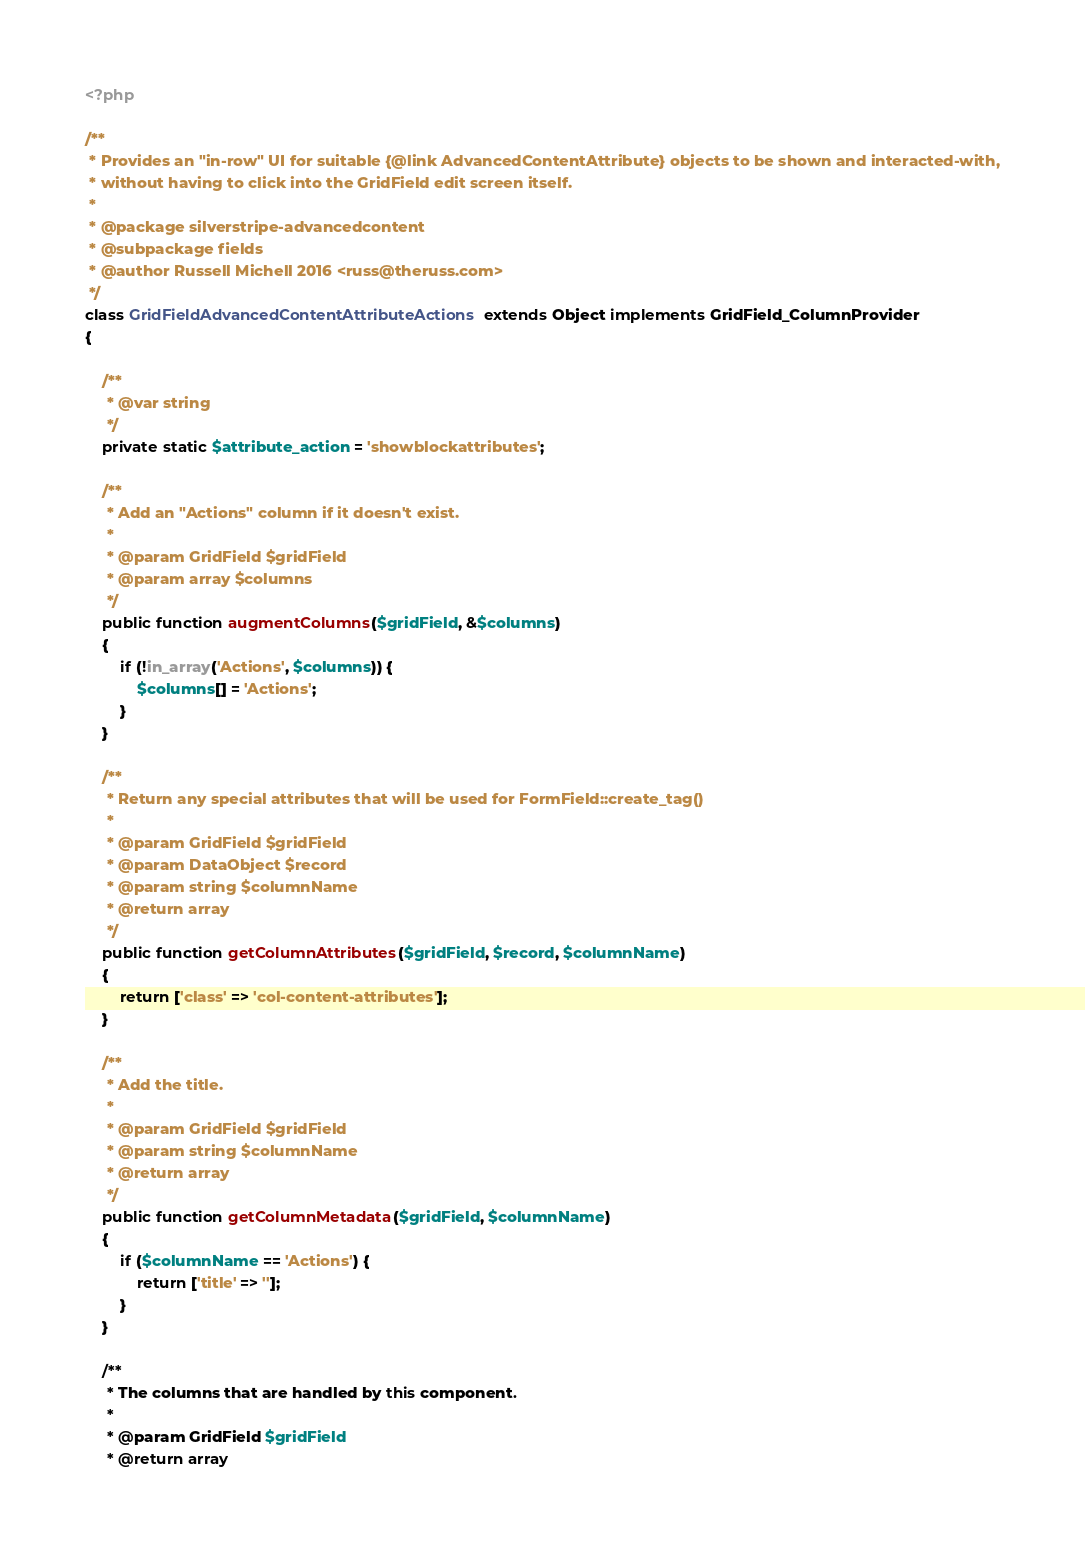<code> <loc_0><loc_0><loc_500><loc_500><_PHP_><?php

/**
 * Provides an "in-row" UI for suitable {@link AdvancedContentAttribute} objects to be shown and interacted-with,
 * without having to click into the GridField edit screen itself.
 * 
 * @package silverstripe-advancedcontent
 * @subpackage fields
 * @author Russell Michell 2016 <russ@theruss.com>
 */
class GridFieldAdvancedContentAttributeActions extends Object implements GridField_ColumnProvider
{

    /**
     * @var string
     */
    private static $attribute_action = 'showblockattributes';
    
    /**
     * Add an "Actions" column if it doesn't exist.
     * 
     * @param GridField $gridField
     * @param array $columns
     */
    public function augmentColumns($gridField, &$columns)
    {
        if (!in_array('Actions', $columns)) {
            $columns[] = 'Actions';
        }
    }

    /**
     * Return any special attributes that will be used for FormField::create_tag()
     * 
     * @param GridField $gridField
     * @param DataObject $record
     * @param string $columnName
     * @return array
     */
    public function getColumnAttributes($gridField, $record, $columnName)
    {
        return ['class' => 'col-content-attributes'];
    }

    /**
     * Add the title.
     * 
     * @param GridField $gridField
     * @param string $columnName
     * @return array
     */
    public function getColumnMetadata($gridField, $columnName)
    {
        if ($columnName == 'Actions') {
            return ['title' => ''];
        }
    }

    /**
     * The columns that are handled by this component.
     * 
     * @param GridField $gridField
     * @return array</code> 